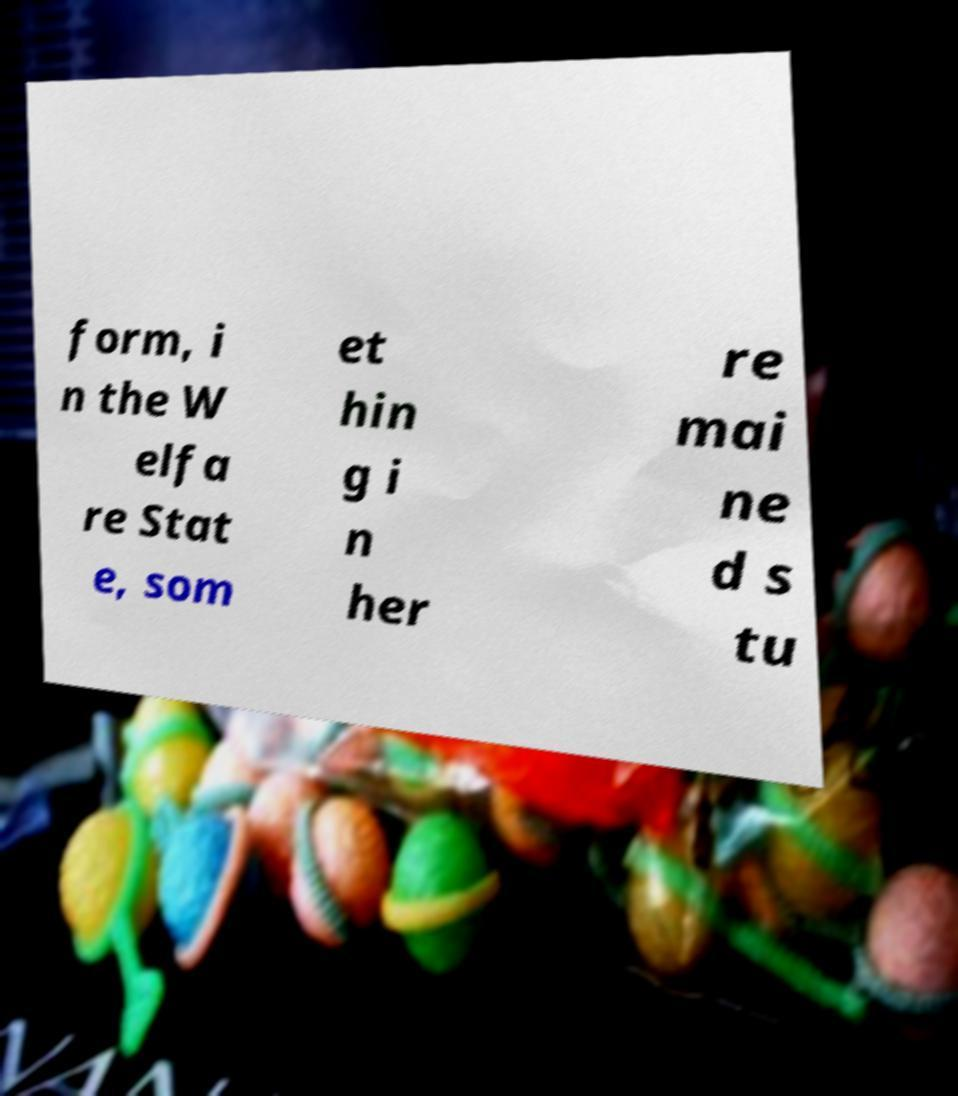Can you accurately transcribe the text from the provided image for me? form, i n the W elfa re Stat e, som et hin g i n her re mai ne d s tu 